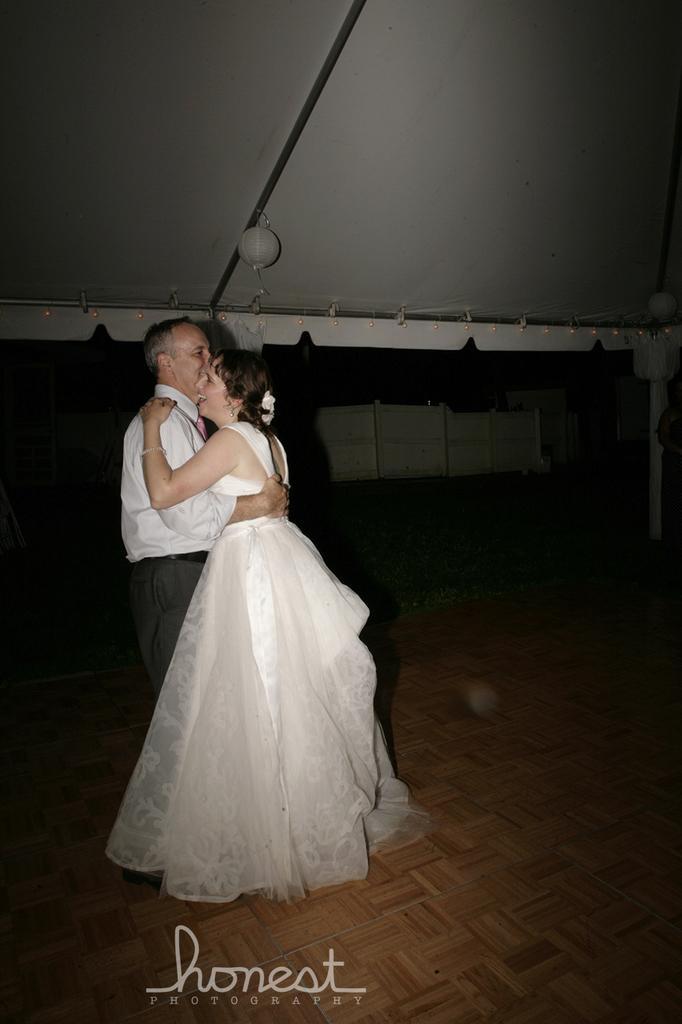Could you give a brief overview of what you see in this image? In this picture we can see a man and a woman holding each other. There is some text at the bottom. We can see a white object on top. 